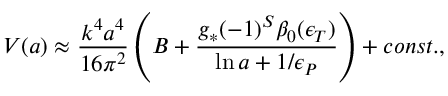Convert formula to latex. <formula><loc_0><loc_0><loc_500><loc_500>{ V } ( a ) \approx { \frac { k ^ { 4 } a ^ { 4 } } { 1 6 \pi ^ { 2 } } } \left ( B + { \frac { g _ { * } ( - 1 ) ^ { S } \beta _ { 0 } ( \epsilon _ { T } ) } { \ln a + { 1 / \epsilon _ { P } } } } \right ) + c o n s t . ,</formula> 